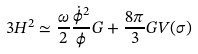Convert formula to latex. <formula><loc_0><loc_0><loc_500><loc_500>3 H ^ { 2 } \simeq \frac { \omega } { 2 } \frac { \dot { \phi } ^ { 2 } } \phi G + \frac { 8 \pi } 3 G V ( \sigma )</formula> 